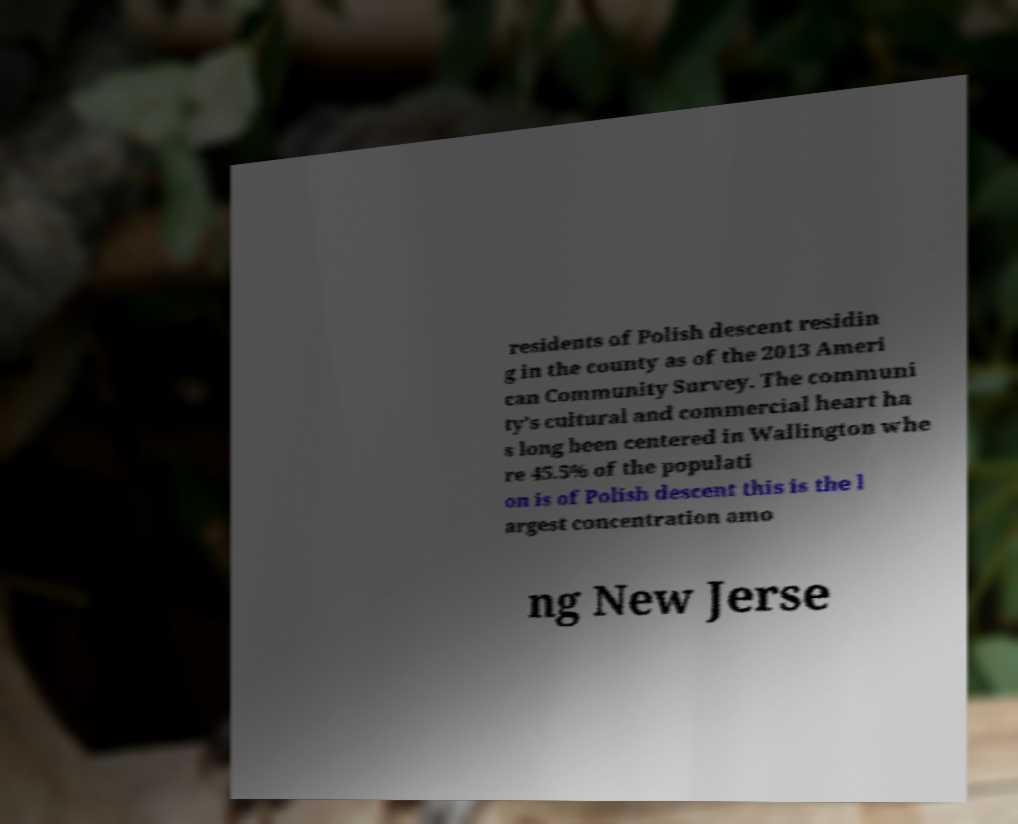For documentation purposes, I need the text within this image transcribed. Could you provide that? residents of Polish descent residin g in the county as of the 2013 Ameri can Community Survey. The communi ty's cultural and commercial heart ha s long been centered in Wallington whe re 45.5% of the populati on is of Polish descent this is the l argest concentration amo ng New Jerse 